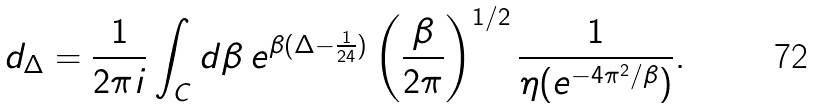<formula> <loc_0><loc_0><loc_500><loc_500>d _ { \Delta } = \frac { 1 } { 2 \pi i } \int _ { C } d \beta \, e ^ { \beta ( \Delta - \frac { 1 } { 2 4 } ) } \left ( \frac { \beta } { 2 \pi } \right ) ^ { 1 / 2 } \frac { 1 } { \eta ( e ^ { - 4 \pi ^ { 2 } / \beta } ) } .</formula> 